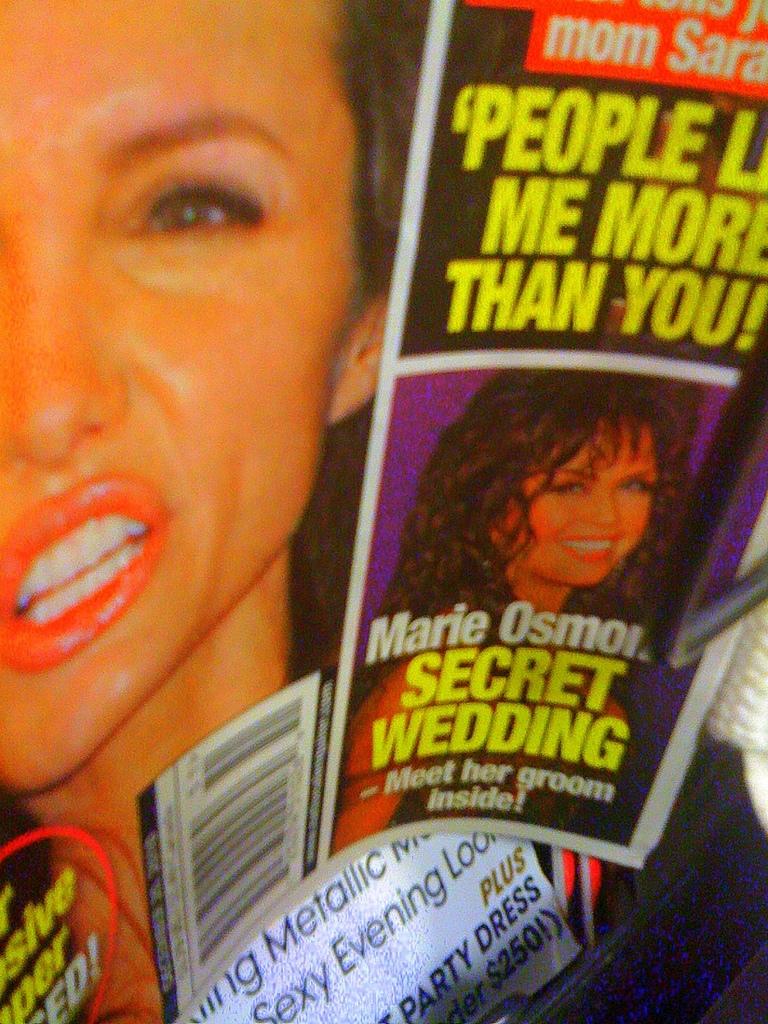Who's secret wedding is the magazine talking about?
Offer a very short reply. Marie osmond. What clothing is written under the word plus?
Keep it short and to the point. Party dress. 